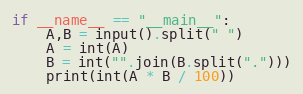Convert code to text. <code><loc_0><loc_0><loc_500><loc_500><_Python_>if __name__ == "__main__":
    A,B = input().split(" ")
    A = int(A)
    B = int("".join(B.split(".")))
    print(int(A * B / 100))
</code> 